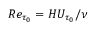<formula> <loc_0><loc_0><loc_500><loc_500>R e _ { \tau _ { 0 } } = H U _ { \tau _ { 0 } } / \nu</formula> 